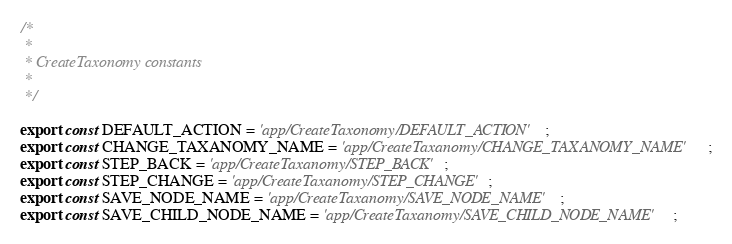<code> <loc_0><loc_0><loc_500><loc_500><_JavaScript_>/*
 *
 * CreateTaxonomy constants
 *
 */

export const DEFAULT_ACTION = 'app/CreateTaxonomy/DEFAULT_ACTION';
export const CHANGE_TAXANOMY_NAME = 'app/CreateTaxanomy/CHANGE_TAXANOMY_NAME';
export const STEP_BACK = 'app/CreateTaxanomy/STEP_BACK';
export const STEP_CHANGE = 'app/CreateTaxanomy/STEP_CHANGE';
export const SAVE_NODE_NAME = 'app/CreateTaxanomy/SAVE_NODE_NAME';
export const SAVE_CHILD_NODE_NAME = 'app/CreateTaxanomy/SAVE_CHILD_NODE_NAME';
</code> 